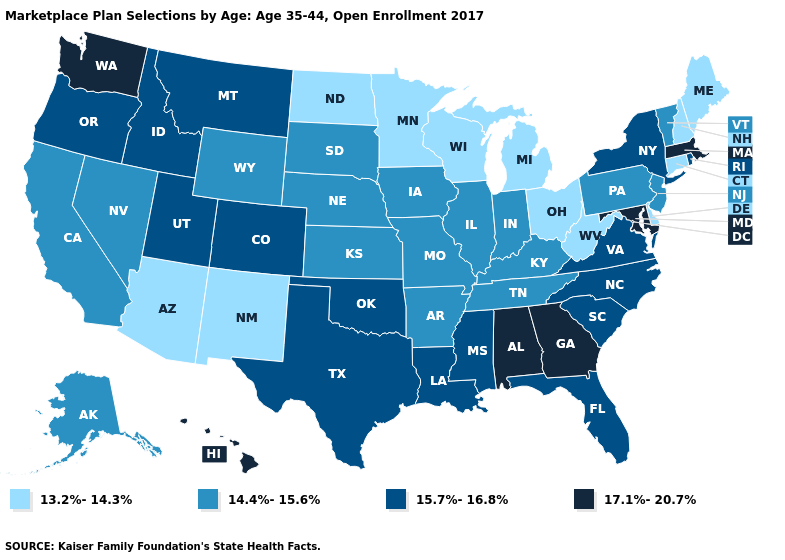What is the value of Ohio?
Be succinct. 13.2%-14.3%. Name the states that have a value in the range 13.2%-14.3%?
Answer briefly. Arizona, Connecticut, Delaware, Maine, Michigan, Minnesota, New Hampshire, New Mexico, North Dakota, Ohio, West Virginia, Wisconsin. What is the value of New York?
Keep it brief. 15.7%-16.8%. What is the value of Idaho?
Write a very short answer. 15.7%-16.8%. Name the states that have a value in the range 13.2%-14.3%?
Write a very short answer. Arizona, Connecticut, Delaware, Maine, Michigan, Minnesota, New Hampshire, New Mexico, North Dakota, Ohio, West Virginia, Wisconsin. Does the first symbol in the legend represent the smallest category?
Concise answer only. Yes. Does Alaska have the highest value in the West?
Be succinct. No. What is the value of New Mexico?
Answer briefly. 13.2%-14.3%. What is the lowest value in the USA?
Answer briefly. 13.2%-14.3%. What is the value of Colorado?
Answer briefly. 15.7%-16.8%. Does Maryland have the highest value in the USA?
Be succinct. Yes. What is the lowest value in the USA?
Keep it brief. 13.2%-14.3%. What is the value of Nevada?
Keep it brief. 14.4%-15.6%. What is the value of West Virginia?
Keep it brief. 13.2%-14.3%. 